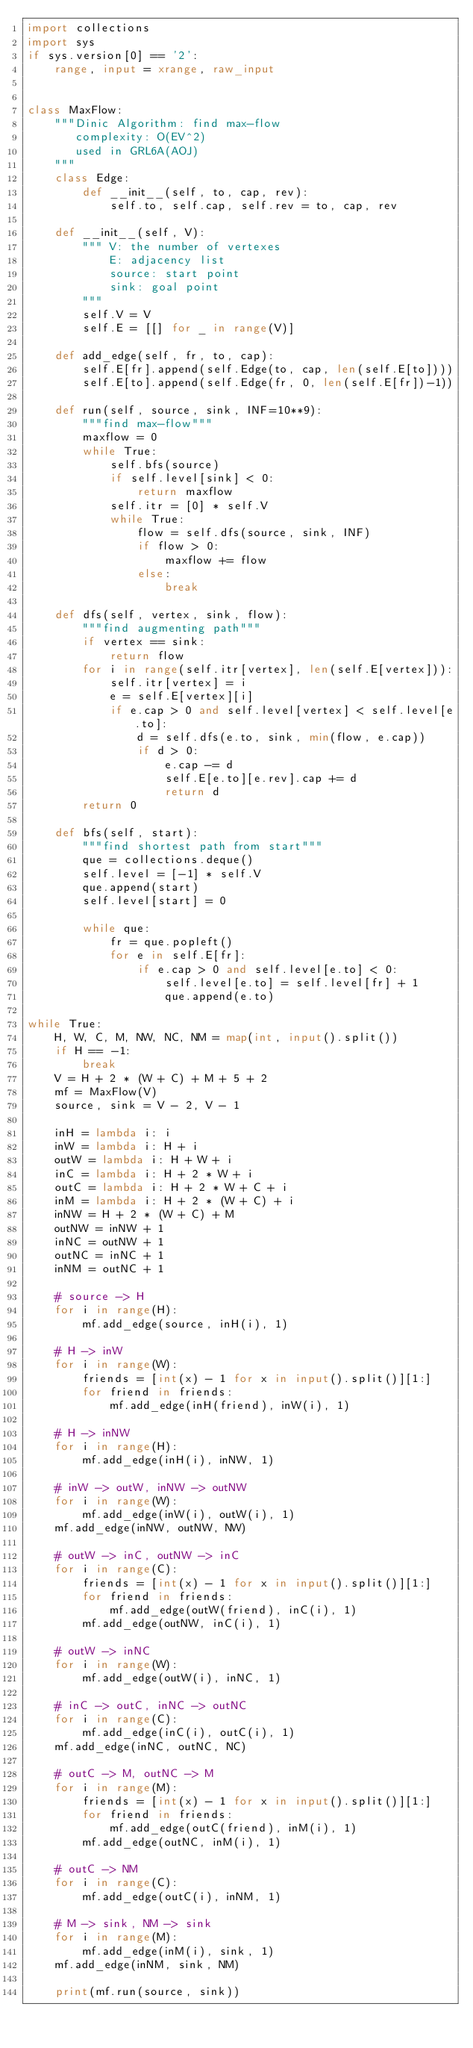Convert code to text. <code><loc_0><loc_0><loc_500><loc_500><_Python_>import collections
import sys
if sys.version[0] == '2':
    range, input = xrange, raw_input


class MaxFlow:
    """Dinic Algorithm: find max-flow
       complexity: O(EV^2)
       used in GRL6A(AOJ)
    """
    class Edge:
        def __init__(self, to, cap, rev):
            self.to, self.cap, self.rev = to, cap, rev

    def __init__(self, V):
        """ V: the number of vertexes
            E: adjacency list
            source: start point
            sink: goal point
        """
        self.V = V
        self.E = [[] for _ in range(V)]

    def add_edge(self, fr, to, cap):
        self.E[fr].append(self.Edge(to, cap, len(self.E[to])))
        self.E[to].append(self.Edge(fr, 0, len(self.E[fr])-1))

    def run(self, source, sink, INF=10**9):
        """find max-flow"""
        maxflow = 0
        while True:
            self.bfs(source)
            if self.level[sink] < 0:
                return maxflow
            self.itr = [0] * self.V
            while True:
                flow = self.dfs(source, sink, INF)
                if flow > 0:
                    maxflow += flow
                else:
                    break

    def dfs(self, vertex, sink, flow):
        """find augmenting path"""
        if vertex == sink:
            return flow
        for i in range(self.itr[vertex], len(self.E[vertex])):
            self.itr[vertex] = i
            e = self.E[vertex][i]
            if e.cap > 0 and self.level[vertex] < self.level[e.to]:
                d = self.dfs(e.to, sink, min(flow, e.cap))
                if d > 0:
                    e.cap -= d
                    self.E[e.to][e.rev].cap += d
                    return d
        return 0

    def bfs(self, start):
        """find shortest path from start"""
        que = collections.deque()
        self.level = [-1] * self.V
        que.append(start)
        self.level[start] = 0

        while que:
            fr = que.popleft()
            for e in self.E[fr]:
                if e.cap > 0 and self.level[e.to] < 0:
                    self.level[e.to] = self.level[fr] + 1
                    que.append(e.to)

while True:
    H, W, C, M, NW, NC, NM = map(int, input().split())
    if H == -1:
        break
    V = H + 2 * (W + C) + M + 5 + 2
    mf = MaxFlow(V)
    source, sink = V - 2, V - 1

    inH = lambda i: i
    inW = lambda i: H + i
    outW = lambda i: H + W + i
    inC = lambda i: H + 2 * W + i
    outC = lambda i: H + 2 * W + C + i
    inM = lambda i: H + 2 * (W + C) + i
    inNW = H + 2 * (W + C) + M
    outNW = inNW + 1
    inNC = outNW + 1
    outNC = inNC + 1
    inNM = outNC + 1

    # source -> H
    for i in range(H):
        mf.add_edge(source, inH(i), 1)

    # H -> inW
    for i in range(W):
        friends = [int(x) - 1 for x in input().split()][1:]
        for friend in friends:
            mf.add_edge(inH(friend), inW(i), 1)

    # H -> inNW
    for i in range(H):
        mf.add_edge(inH(i), inNW, 1)

    # inW -> outW, inNW -> outNW
    for i in range(W):
        mf.add_edge(inW(i), outW(i), 1)
    mf.add_edge(inNW, outNW, NW)

    # outW -> inC, outNW -> inC
    for i in range(C):
        friends = [int(x) - 1 for x in input().split()][1:]
        for friend in friends:
            mf.add_edge(outW(friend), inC(i), 1)
        mf.add_edge(outNW, inC(i), 1)

    # outW -> inNC
    for i in range(W):
        mf.add_edge(outW(i), inNC, 1)

    # inC -> outC, inNC -> outNC
    for i in range(C):
        mf.add_edge(inC(i), outC(i), 1)
    mf.add_edge(inNC, outNC, NC)

    # outC -> M, outNC -> M
    for i in range(M):
        friends = [int(x) - 1 for x in input().split()][1:]
        for friend in friends:
            mf.add_edge(outC(friend), inM(i), 1)
        mf.add_edge(outNC, inM(i), 1)

    # outC -> NM
    for i in range(C):
        mf.add_edge(outC(i), inNM, 1)

    # M -> sink, NM -> sink
    for i in range(M):
        mf.add_edge(inM(i), sink, 1)
    mf.add_edge(inNM, sink, NM)

    print(mf.run(source, sink))</code> 